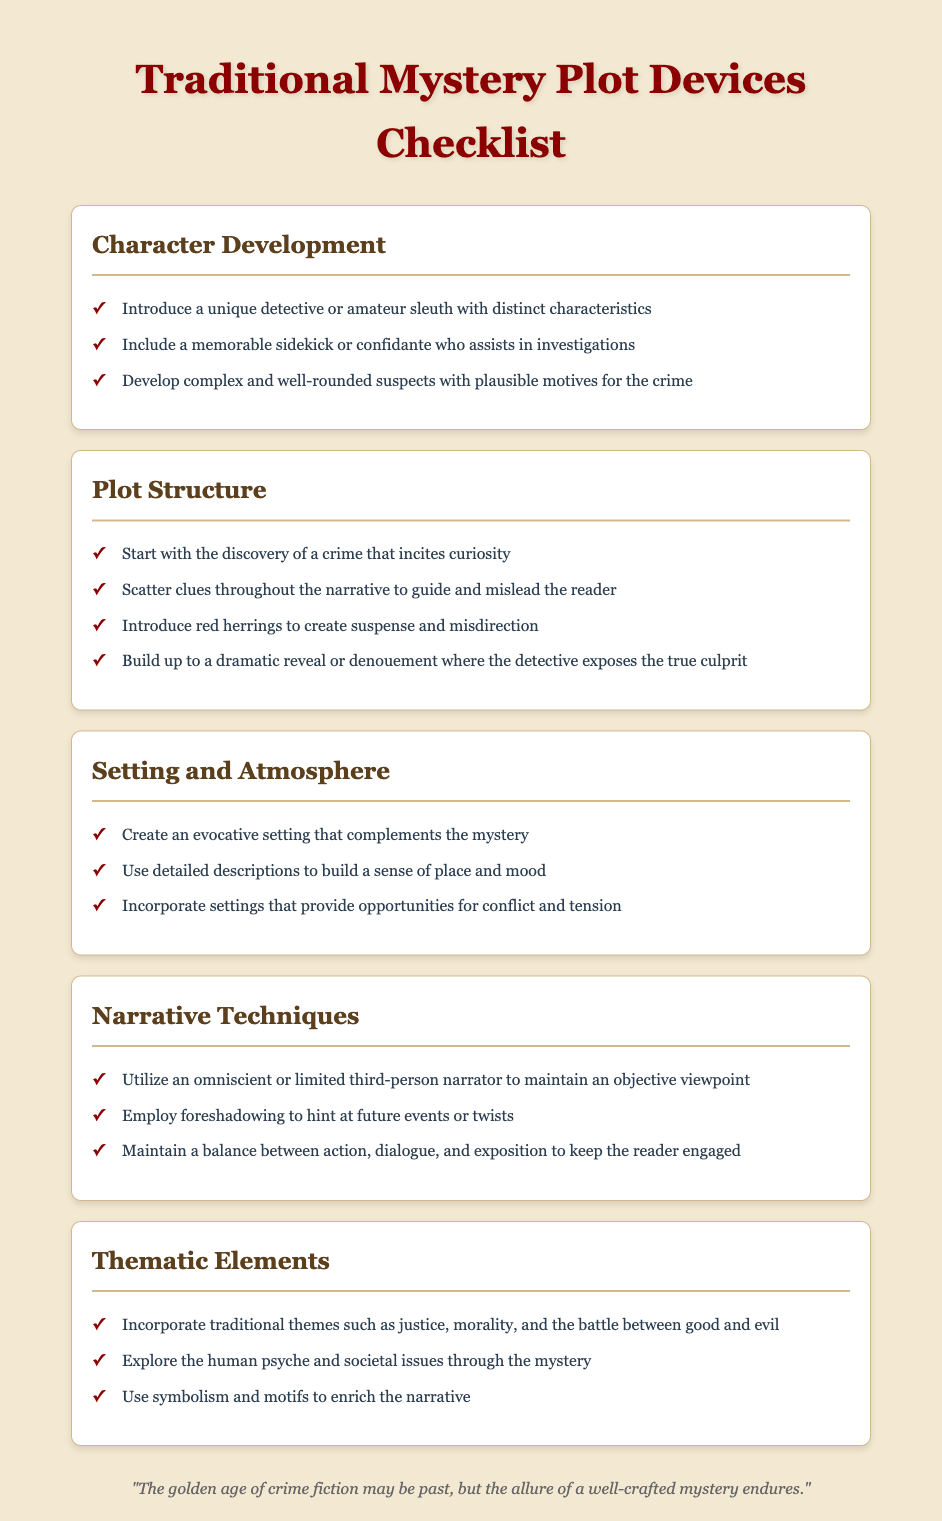What is the title of the document? The title of the document is presented prominently at the top of the rendered content.
Answer: Traditional Mystery Plot Devices Checklist How many sections are included in the checklist? The document has five distinct sections that categorize different plot devices.
Answer: 5 What is one type of character mentioned in the Character Development section? The Character Development section specifies the inclusion of specific character types, particularly in relation to detectives.
Answer: detective What is a key aspect of the Plot Structure according to the checklist? The Plot Structure section outlines essential components such as the introduction of crime and the placement of clues.
Answer: clues What is the main theme addressed in the Thematic Elements section? The Thematic Elements section highlights traditional themes that are crucial to mysteries.
Answer: justice Name one narrative technique highlighted in the document. The Narrative Techniques section discusses various techniques that help to enhance storytelling in mysteries.
Answer: foreshadowing What type of narration is suggested for maintaining an objective viewpoint? The document provides guidance on narrative perspectives that can shape the reader's experience.
Answer: third-person What is a crucial setting characteristic mentioned in the checklist? The Setting and Atmosphere section outlines attributes that are vital to enhancing the mystery ambiance.
Answer: evocative setting 